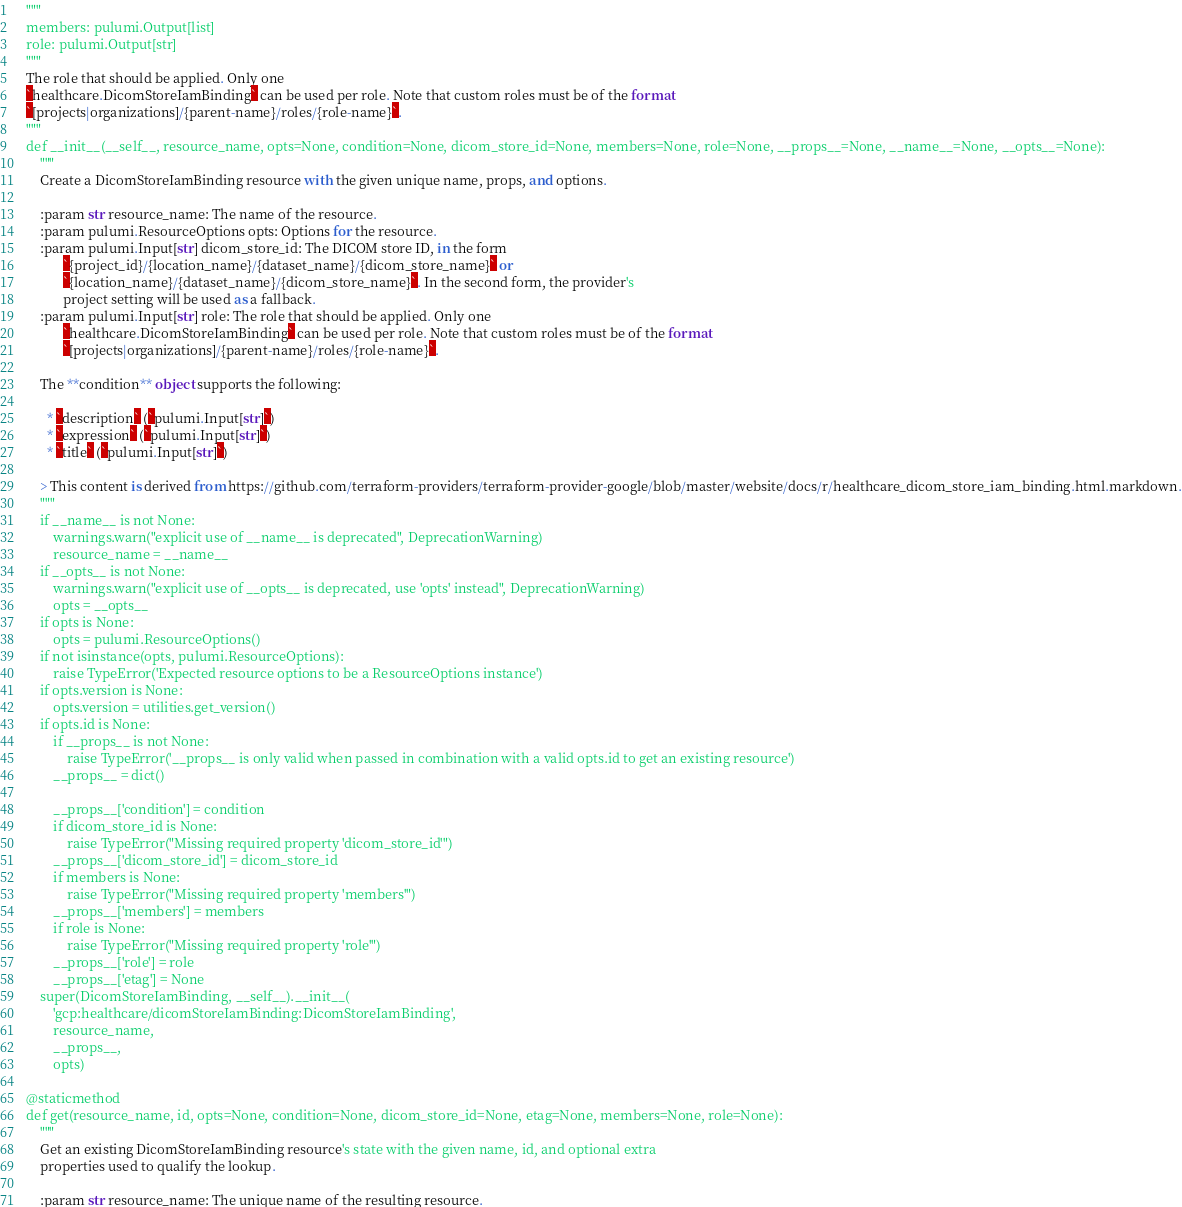<code> <loc_0><loc_0><loc_500><loc_500><_Python_>    """
    members: pulumi.Output[list]
    role: pulumi.Output[str]
    """
    The role that should be applied. Only one
    `healthcare.DicomStoreIamBinding` can be used per role. Note that custom roles must be of the format
    `[projects|organizations]/{parent-name}/roles/{role-name}`.
    """
    def __init__(__self__, resource_name, opts=None, condition=None, dicom_store_id=None, members=None, role=None, __props__=None, __name__=None, __opts__=None):
        """
        Create a DicomStoreIamBinding resource with the given unique name, props, and options.
        
        :param str resource_name: The name of the resource.
        :param pulumi.ResourceOptions opts: Options for the resource.
        :param pulumi.Input[str] dicom_store_id: The DICOM store ID, in the form
               `{project_id}/{location_name}/{dataset_name}/{dicom_store_name}` or
               `{location_name}/{dataset_name}/{dicom_store_name}`. In the second form, the provider's
               project setting will be used as a fallback.
        :param pulumi.Input[str] role: The role that should be applied. Only one
               `healthcare.DicomStoreIamBinding` can be used per role. Note that custom roles must be of the format
               `[projects|organizations]/{parent-name}/roles/{role-name}`.
        
        The **condition** object supports the following:
        
          * `description` (`pulumi.Input[str]`)
          * `expression` (`pulumi.Input[str]`)
          * `title` (`pulumi.Input[str]`)

        > This content is derived from https://github.com/terraform-providers/terraform-provider-google/blob/master/website/docs/r/healthcare_dicom_store_iam_binding.html.markdown.
        """
        if __name__ is not None:
            warnings.warn("explicit use of __name__ is deprecated", DeprecationWarning)
            resource_name = __name__
        if __opts__ is not None:
            warnings.warn("explicit use of __opts__ is deprecated, use 'opts' instead", DeprecationWarning)
            opts = __opts__
        if opts is None:
            opts = pulumi.ResourceOptions()
        if not isinstance(opts, pulumi.ResourceOptions):
            raise TypeError('Expected resource options to be a ResourceOptions instance')
        if opts.version is None:
            opts.version = utilities.get_version()
        if opts.id is None:
            if __props__ is not None:
                raise TypeError('__props__ is only valid when passed in combination with a valid opts.id to get an existing resource')
            __props__ = dict()

            __props__['condition'] = condition
            if dicom_store_id is None:
                raise TypeError("Missing required property 'dicom_store_id'")
            __props__['dicom_store_id'] = dicom_store_id
            if members is None:
                raise TypeError("Missing required property 'members'")
            __props__['members'] = members
            if role is None:
                raise TypeError("Missing required property 'role'")
            __props__['role'] = role
            __props__['etag'] = None
        super(DicomStoreIamBinding, __self__).__init__(
            'gcp:healthcare/dicomStoreIamBinding:DicomStoreIamBinding',
            resource_name,
            __props__,
            opts)

    @staticmethod
    def get(resource_name, id, opts=None, condition=None, dicom_store_id=None, etag=None, members=None, role=None):
        """
        Get an existing DicomStoreIamBinding resource's state with the given name, id, and optional extra
        properties used to qualify the lookup.
        
        :param str resource_name: The unique name of the resulting resource.</code> 